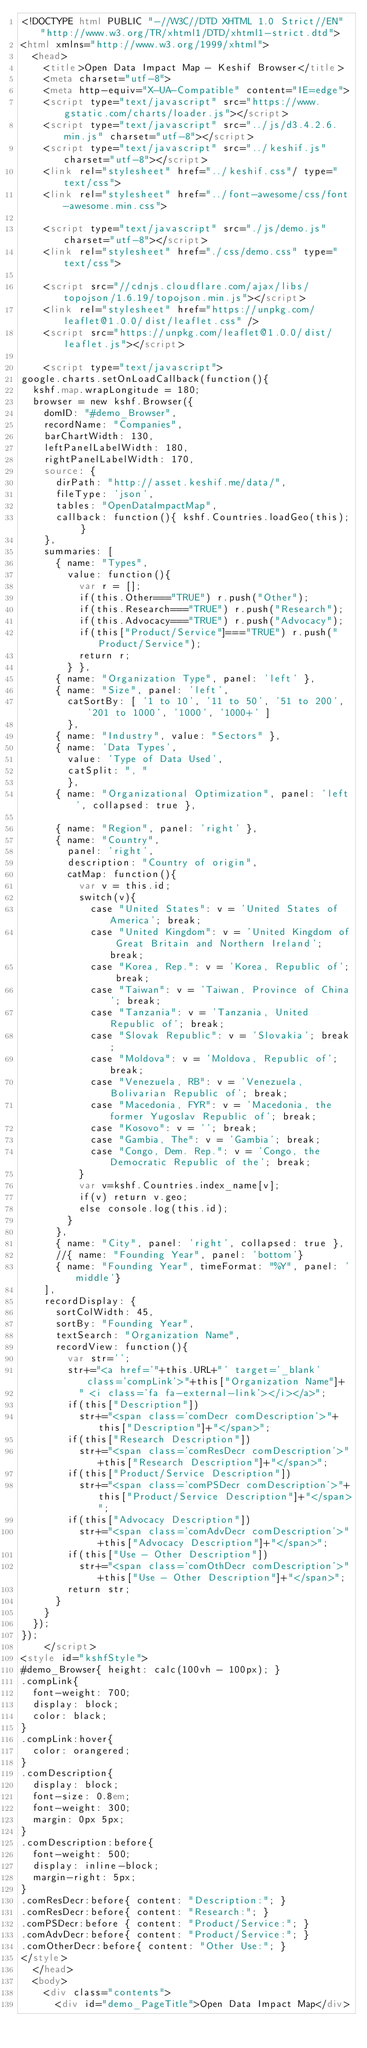<code> <loc_0><loc_0><loc_500><loc_500><_HTML_><!DOCTYPE html PUBLIC "-//W3C//DTD XHTML 1.0 Strict//EN" "http://www.w3.org/TR/xhtml1/DTD/xhtml1-strict.dtd">
<html xmlns="http://www.w3.org/1999/xhtml">
  <head>
    <title>Open Data Impact Map - Keshif Browser</title>
    <meta charset="utf-8">
    <meta http-equiv="X-UA-Compatible" content="IE=edge">
    <script type="text/javascript" src="https://www.gstatic.com/charts/loader.js"></script>
    <script type="text/javascript" src="../js/d3.4.2.6.min.js" charset="utf-8"></script>
    <script type="text/javascript" src="../keshif.js" charset="utf-8"></script>
    <link rel="stylesheet" href="../keshif.css"/ type="text/css">
    <link rel="stylesheet" href="../font-awesome/css/font-awesome.min.css">

    <script type="text/javascript" src="./js/demo.js" charset="utf-8"></script>
    <link rel="stylesheet" href="./css/demo.css" type="text/css">

    <script src="//cdnjs.cloudflare.com/ajax/libs/topojson/1.6.19/topojson.min.js"></script>
    <link rel="stylesheet" href="https://unpkg.com/leaflet@1.0.0/dist/leaflet.css" />
    <script src="https://unpkg.com/leaflet@1.0.0/dist/leaflet.js"></script>

    <script type="text/javascript">
google.charts.setOnLoadCallback(function(){
  kshf.map.wrapLongitude = 180;
  browser = new kshf.Browser({
    domID: "#demo_Browser",
    recordName: "Companies",
    barChartWidth: 130,
    leftPanelLabelWidth: 180,
    rightPanelLabelWidth: 170,
    source: {
      dirPath: "http://asset.keshif.me/data/",
      fileType: 'json',
      tables: "OpenDataImpactMap",
      callback: function(){ kshf.Countries.loadGeo(this); }
    },
    summaries: [
      { name: "Types",
        value: function(){
          var r = [];
          if(this.Other==="TRUE") r.push("Other");
          if(this.Research==="TRUE") r.push("Research");
          if(this.Advocacy==="TRUE") r.push("Advocacy");
          if(this["Product/Service"]==="TRUE") r.push("Product/Service");
          return r;
        } },
      { name: "Organization Type", panel: 'left' },
      { name: "Size", panel: 'left',
        catSortBy: [ '1 to 10', '11 to 50', '51 to 200', '201 to 1000', '1000', '1000+' ]
        },
      { name: "Industry", value: "Sectors" },
      { name: 'Data Types',
        value: 'Type of Data Used', 
        catSplit: ", "
        },
      { name: "Organizational Optimization", panel: 'left', collapsed: true },

      { name: "Region", panel: 'right' },
      { name: "Country", 
        panel: 'right',
        description: "Country of origin",
        catMap: function(){
          var v = this.id;
          switch(v){
            case "United States": v = 'United States of America'; break;
            case "United Kingdom": v = 'United Kingdom of Great Britain and Northern Ireland'; break;
            case "Korea, Rep.": v = 'Korea, Republic of'; break;
            case "Taiwan": v = 'Taiwan, Province of China'; break;
            case "Tanzania": v = 'Tanzania, United Republic of'; break;
            case "Slovak Republic": v = 'Slovakia'; break;
            case "Moldova": v = 'Moldova, Republic of'; break;
            case "Venezuela, RB": v = 'Venezuela, Bolivarian Republic of'; break;
            case "Macedonia, FYR": v = 'Macedonia, the former Yugoslav Republic of'; break;
            case "Kosovo": v = ''; break;
            case "Gambia, The": v = 'Gambia'; break;
            case "Congo, Dem. Rep.": v = 'Congo, the Democratic Republic of the'; break;
          }
          var v=kshf.Countries.index_name[v];
          if(v) return v.geo;
          else console.log(this.id);
        }
      },
      { name: "City", panel: 'right', collapsed: true },
      //{ name: "Founding Year", panel: 'bottom'}
      { name: "Founding Year", timeFormat: "%Y", panel: 'middle'}
    ],
    recordDisplay: {
      sortColWidth: 45,
      sortBy: "Founding Year",
      textSearch: "Organization Name",
      recordView: function(){
        var str='';
        str+="<a href='"+this.URL+"' target='_blank' class='compLink'>"+this["Organization Name"]+
          " <i class='fa fa-external-link'></i></a>";
        if(this["Description"]) 
          str+="<span class='comDecr comDescription'>"+this["Description"]+"</span>";
        if(this["Research Description"]) 
          str+="<span class='comResDecr comDescription'>"+this["Research Description"]+"</span>";
        if(this["Product/Service Description"]) 
          str+="<span class='comPSDecr comDescription'>"+this["Product/Service Description"]+"</span>";
        if(this["Advocacy Description"]) 
          str+="<span class='comAdvDecr comDescription'>"+this["Advocacy Description"]+"</span>";
        if(this["Use - Other Description"]) 
          str+="<span class='comOthDecr comDescription'>"+this["Use - Other Description"]+"</span>";
        return str;
      }
    }
  });
});
    </script>
<style id="kshfStyle">
#demo_Browser{ height: calc(100vh - 100px); }
.compLink{
  font-weight: 700;
  display: block;
  color: black;
}
.compLink:hover{
  color: orangered;
}
.comDescription{
  display: block;
  font-size: 0.8em;
  font-weight: 300;
  margin: 0px 5px;
}
.comDescription:before{
  font-weight: 500;
  display: inline-block;
  margin-right: 5px;
}
.comResDecr:before{ content: "Description:"; }
.comResDecr:before{ content: "Research:"; }
.comPSDecr:before { content: "Product/Service:"; }
.comAdvDecr:before{ content: "Product/Service:"; }
.comOtherDecr:before{ content: "Other Use:"; }
</style>
  </head>
  <body>
    <div class="contents">
      <div id="demo_PageTitle">Open Data Impact Map</div></code> 